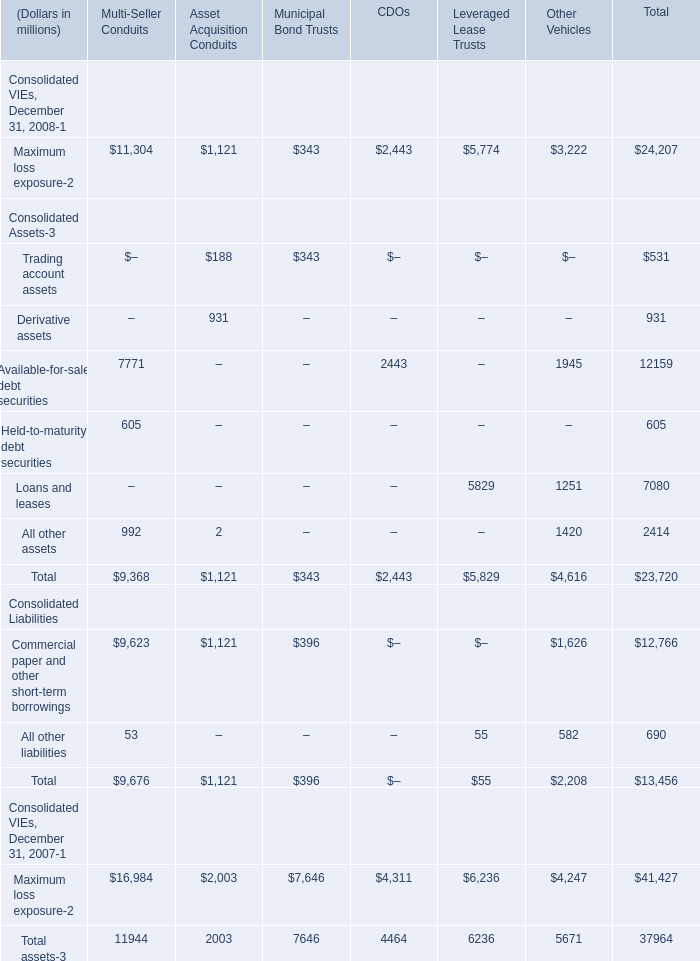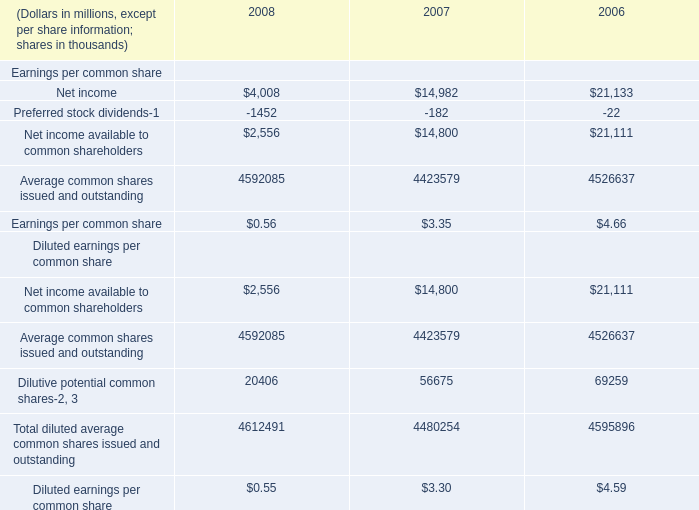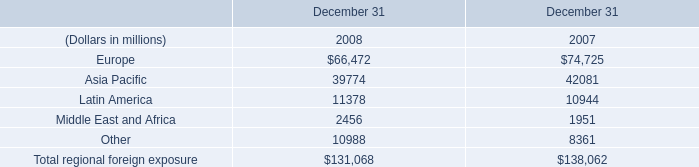What is the sum of Latin America of December 31 2007, and Maximum loss exposure of Leveraged Lease Trusts ? 
Computations: (10944.0 + 5774.0)
Answer: 16718.0. 